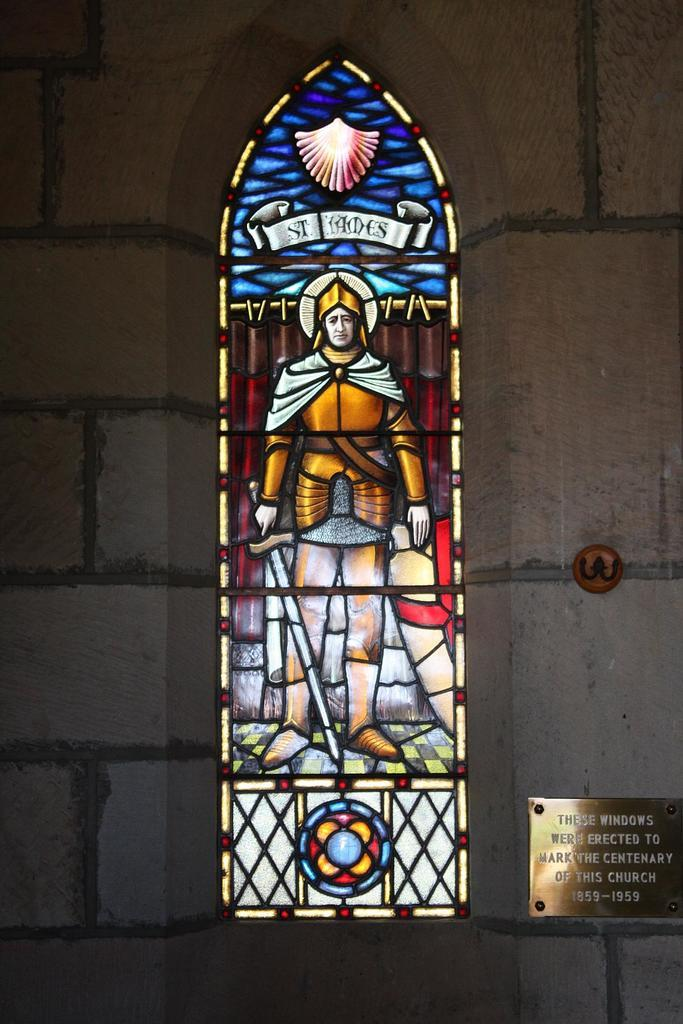What type of structure is present in the image? There is a glass window in the image. What is depicted on the glass window? The glass window has a depiction of a person holding a sword. What else can be seen in the image besides the glass window? There is a wall and a text board attached to the wall in the image. Can you tell me the color of the tongue on the person holding the sword in the image? There is no tongue visible in the image, as it features a depiction of a person holding a sword on a glass window. 